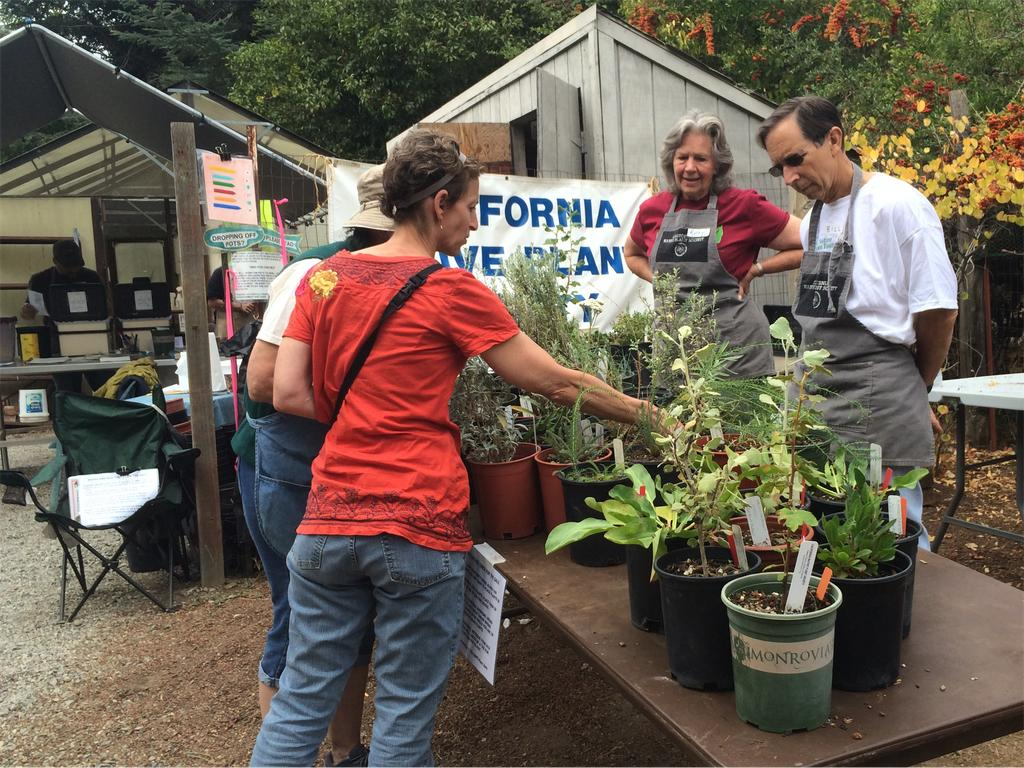What is on the table in the image? There is a table with plants in the image. What are the people around the table doing? People are standing around the table. What can be seen near the table in the image? There are sheds with banners in the image. What is visible in the background of the image? Trees are visible in the background of the image. What type of toothbrush is being used to water the plants on the table? There is no toothbrush present in the image, and the plants are not being watered. 